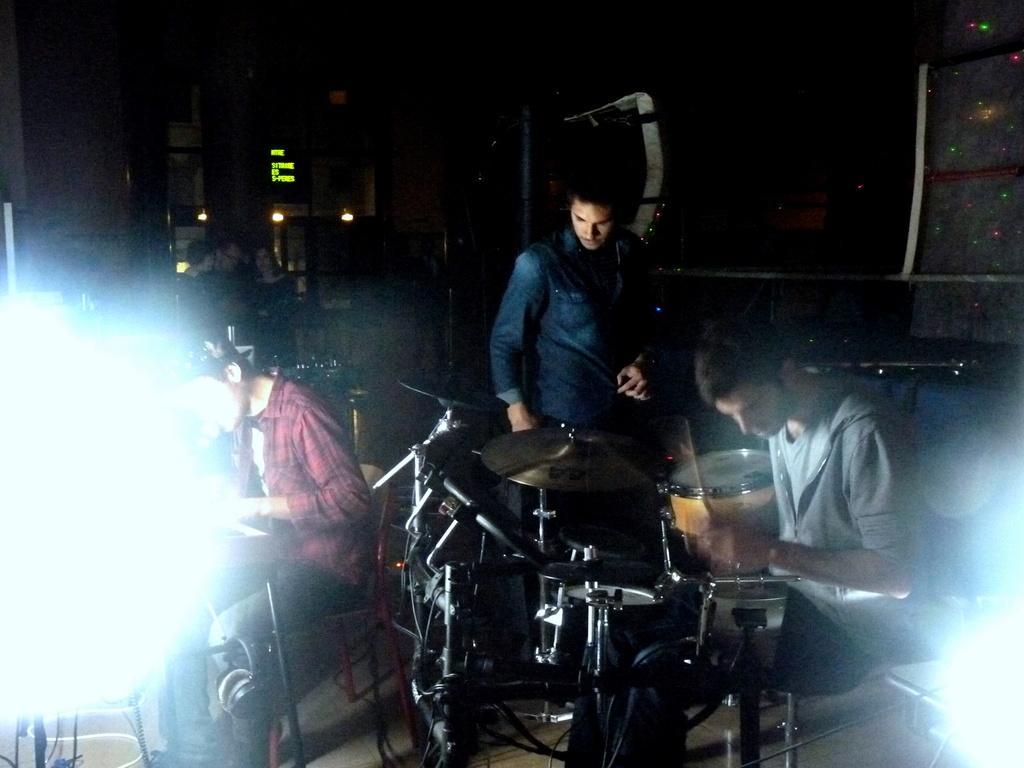In one or two sentences, can you explain what this image depicts? It is a music show inside the restaurant there are three people who are playing the music ,behind them there are some people sitting ,in the background there is a LED display board few lights and a wall. 